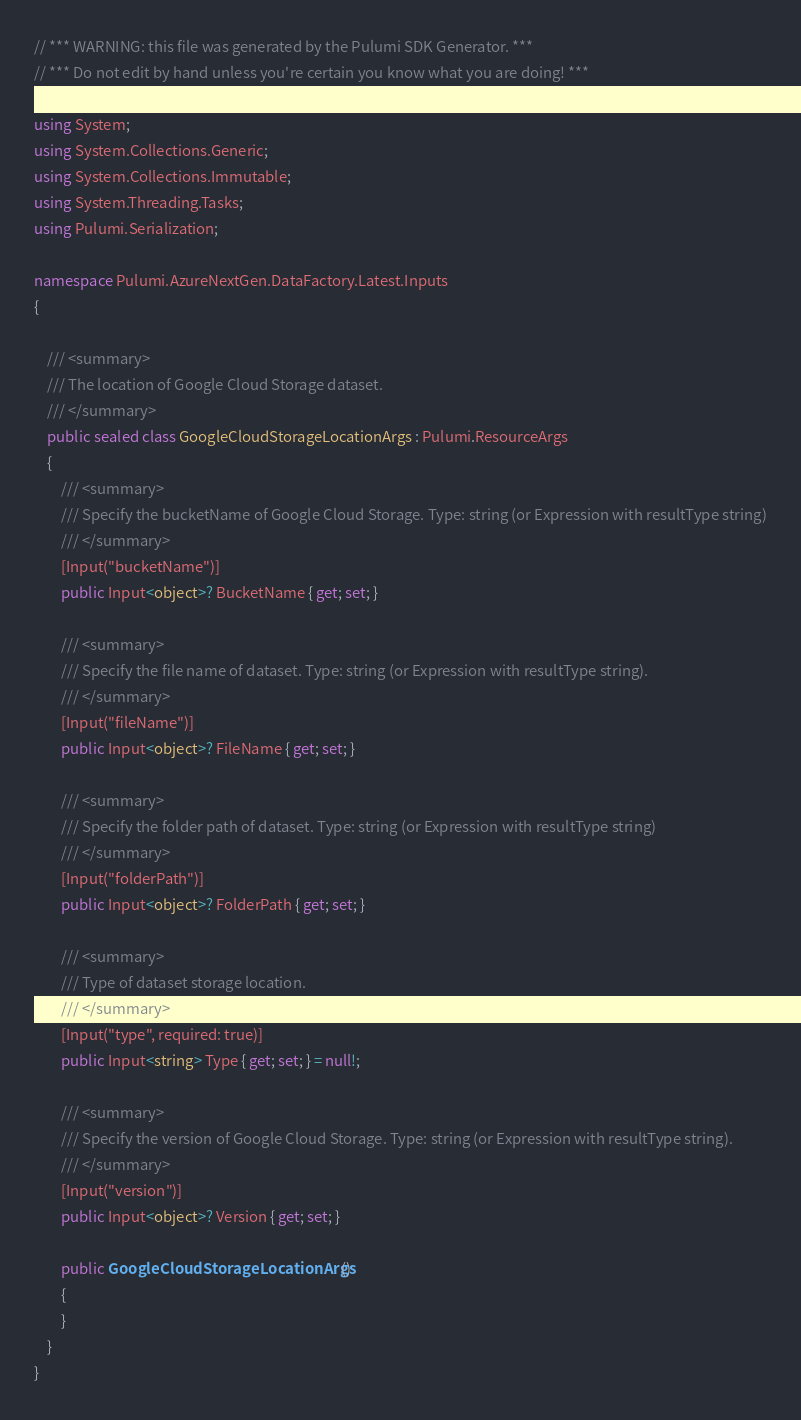<code> <loc_0><loc_0><loc_500><loc_500><_C#_>// *** WARNING: this file was generated by the Pulumi SDK Generator. ***
// *** Do not edit by hand unless you're certain you know what you are doing! ***

using System;
using System.Collections.Generic;
using System.Collections.Immutable;
using System.Threading.Tasks;
using Pulumi.Serialization;

namespace Pulumi.AzureNextGen.DataFactory.Latest.Inputs
{

    /// <summary>
    /// The location of Google Cloud Storage dataset.
    /// </summary>
    public sealed class GoogleCloudStorageLocationArgs : Pulumi.ResourceArgs
    {
        /// <summary>
        /// Specify the bucketName of Google Cloud Storage. Type: string (or Expression with resultType string)
        /// </summary>
        [Input("bucketName")]
        public Input<object>? BucketName { get; set; }

        /// <summary>
        /// Specify the file name of dataset. Type: string (or Expression with resultType string).
        /// </summary>
        [Input("fileName")]
        public Input<object>? FileName { get; set; }

        /// <summary>
        /// Specify the folder path of dataset. Type: string (or Expression with resultType string)
        /// </summary>
        [Input("folderPath")]
        public Input<object>? FolderPath { get; set; }

        /// <summary>
        /// Type of dataset storage location.
        /// </summary>
        [Input("type", required: true)]
        public Input<string> Type { get; set; } = null!;

        /// <summary>
        /// Specify the version of Google Cloud Storage. Type: string (or Expression with resultType string).
        /// </summary>
        [Input("version")]
        public Input<object>? Version { get; set; }

        public GoogleCloudStorageLocationArgs()
        {
        }
    }
}
</code> 